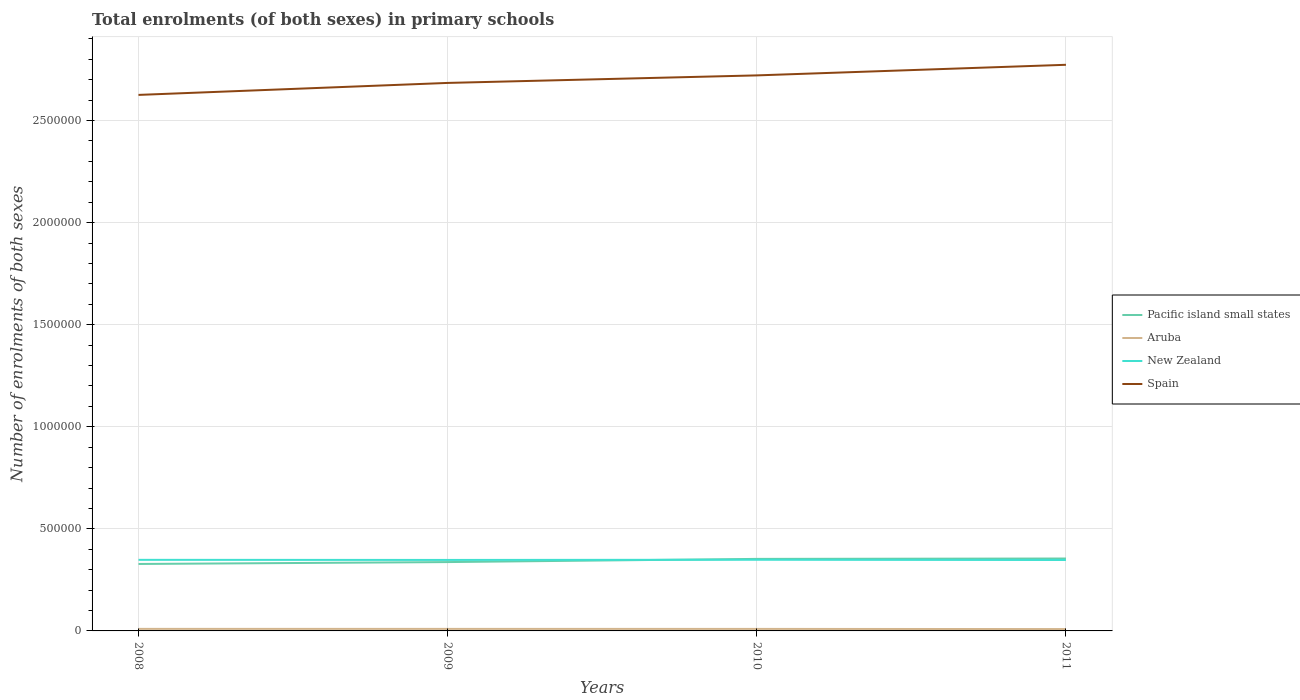How many different coloured lines are there?
Your answer should be very brief. 4. Does the line corresponding to New Zealand intersect with the line corresponding to Pacific island small states?
Your answer should be very brief. Yes. Across all years, what is the maximum number of enrolments in primary schools in New Zealand?
Ensure brevity in your answer.  3.47e+05. What is the total number of enrolments in primary schools in Aruba in the graph?
Your response must be concise. 86. What is the difference between the highest and the second highest number of enrolments in primary schools in Spain?
Keep it short and to the point. 1.47e+05. What is the difference between the highest and the lowest number of enrolments in primary schools in Spain?
Your response must be concise. 2. How many lines are there?
Offer a very short reply. 4. Where does the legend appear in the graph?
Your answer should be compact. Center right. How are the legend labels stacked?
Offer a terse response. Vertical. What is the title of the graph?
Provide a short and direct response. Total enrolments (of both sexes) in primary schools. Does "Dominican Republic" appear as one of the legend labels in the graph?
Make the answer very short. No. What is the label or title of the X-axis?
Keep it short and to the point. Years. What is the label or title of the Y-axis?
Offer a very short reply. Number of enrolments of both sexes. What is the Number of enrolments of both sexes of Pacific island small states in 2008?
Your answer should be compact. 3.28e+05. What is the Number of enrolments of both sexes in Aruba in 2008?
Ensure brevity in your answer.  1.00e+04. What is the Number of enrolments of both sexes in New Zealand in 2008?
Ensure brevity in your answer.  3.48e+05. What is the Number of enrolments of both sexes of Spain in 2008?
Give a very brief answer. 2.63e+06. What is the Number of enrolments of both sexes in Pacific island small states in 2009?
Keep it short and to the point. 3.37e+05. What is the Number of enrolments of both sexes in Aruba in 2009?
Keep it short and to the point. 9944. What is the Number of enrolments of both sexes of New Zealand in 2009?
Give a very brief answer. 3.48e+05. What is the Number of enrolments of both sexes of Spain in 2009?
Ensure brevity in your answer.  2.68e+06. What is the Number of enrolments of both sexes of Pacific island small states in 2010?
Keep it short and to the point. 3.53e+05. What is the Number of enrolments of both sexes in Aruba in 2010?
Give a very brief answer. 9858. What is the Number of enrolments of both sexes of New Zealand in 2010?
Offer a very short reply. 3.48e+05. What is the Number of enrolments of both sexes in Spain in 2010?
Make the answer very short. 2.72e+06. What is the Number of enrolments of both sexes of Pacific island small states in 2011?
Your response must be concise. 3.55e+05. What is the Number of enrolments of both sexes of Aruba in 2011?
Your answer should be very brief. 9112. What is the Number of enrolments of both sexes in New Zealand in 2011?
Offer a terse response. 3.47e+05. What is the Number of enrolments of both sexes of Spain in 2011?
Keep it short and to the point. 2.77e+06. Across all years, what is the maximum Number of enrolments of both sexes in Pacific island small states?
Give a very brief answer. 3.55e+05. Across all years, what is the maximum Number of enrolments of both sexes of Aruba?
Give a very brief answer. 1.00e+04. Across all years, what is the maximum Number of enrolments of both sexes in New Zealand?
Your answer should be very brief. 3.48e+05. Across all years, what is the maximum Number of enrolments of both sexes of Spain?
Your answer should be compact. 2.77e+06. Across all years, what is the minimum Number of enrolments of both sexes of Pacific island small states?
Your answer should be very brief. 3.28e+05. Across all years, what is the minimum Number of enrolments of both sexes of Aruba?
Your answer should be compact. 9112. Across all years, what is the minimum Number of enrolments of both sexes of New Zealand?
Offer a terse response. 3.47e+05. Across all years, what is the minimum Number of enrolments of both sexes of Spain?
Offer a very short reply. 2.63e+06. What is the total Number of enrolments of both sexes in Pacific island small states in the graph?
Keep it short and to the point. 1.37e+06. What is the total Number of enrolments of both sexes of Aruba in the graph?
Provide a short and direct response. 3.89e+04. What is the total Number of enrolments of both sexes of New Zealand in the graph?
Make the answer very short. 1.39e+06. What is the total Number of enrolments of both sexes in Spain in the graph?
Your response must be concise. 1.08e+07. What is the difference between the Number of enrolments of both sexes in Pacific island small states in 2008 and that in 2009?
Your answer should be compact. -9265.12. What is the difference between the Number of enrolments of both sexes of New Zealand in 2008 and that in 2009?
Your response must be concise. 486. What is the difference between the Number of enrolments of both sexes in Spain in 2008 and that in 2009?
Make the answer very short. -5.87e+04. What is the difference between the Number of enrolments of both sexes in Pacific island small states in 2008 and that in 2010?
Make the answer very short. -2.49e+04. What is the difference between the Number of enrolments of both sexes of Aruba in 2008 and that in 2010?
Give a very brief answer. 154. What is the difference between the Number of enrolments of both sexes in New Zealand in 2008 and that in 2010?
Give a very brief answer. -332. What is the difference between the Number of enrolments of both sexes of Spain in 2008 and that in 2010?
Provide a succinct answer. -9.56e+04. What is the difference between the Number of enrolments of both sexes in Pacific island small states in 2008 and that in 2011?
Offer a terse response. -2.67e+04. What is the difference between the Number of enrolments of both sexes of Aruba in 2008 and that in 2011?
Your answer should be compact. 900. What is the difference between the Number of enrolments of both sexes of New Zealand in 2008 and that in 2011?
Your answer should be very brief. 811. What is the difference between the Number of enrolments of both sexes of Spain in 2008 and that in 2011?
Offer a terse response. -1.47e+05. What is the difference between the Number of enrolments of both sexes of Pacific island small states in 2009 and that in 2010?
Keep it short and to the point. -1.56e+04. What is the difference between the Number of enrolments of both sexes of New Zealand in 2009 and that in 2010?
Offer a terse response. -818. What is the difference between the Number of enrolments of both sexes of Spain in 2009 and that in 2010?
Keep it short and to the point. -3.69e+04. What is the difference between the Number of enrolments of both sexes of Pacific island small states in 2009 and that in 2011?
Offer a terse response. -1.75e+04. What is the difference between the Number of enrolments of both sexes in Aruba in 2009 and that in 2011?
Provide a short and direct response. 832. What is the difference between the Number of enrolments of both sexes in New Zealand in 2009 and that in 2011?
Ensure brevity in your answer.  325. What is the difference between the Number of enrolments of both sexes in Spain in 2009 and that in 2011?
Provide a short and direct response. -8.88e+04. What is the difference between the Number of enrolments of both sexes in Pacific island small states in 2010 and that in 2011?
Provide a short and direct response. -1849.88. What is the difference between the Number of enrolments of both sexes in Aruba in 2010 and that in 2011?
Your answer should be very brief. 746. What is the difference between the Number of enrolments of both sexes of New Zealand in 2010 and that in 2011?
Your answer should be compact. 1143. What is the difference between the Number of enrolments of both sexes of Spain in 2010 and that in 2011?
Offer a very short reply. -5.19e+04. What is the difference between the Number of enrolments of both sexes in Pacific island small states in 2008 and the Number of enrolments of both sexes in Aruba in 2009?
Offer a very short reply. 3.18e+05. What is the difference between the Number of enrolments of both sexes in Pacific island small states in 2008 and the Number of enrolments of both sexes in New Zealand in 2009?
Your answer should be compact. -1.98e+04. What is the difference between the Number of enrolments of both sexes of Pacific island small states in 2008 and the Number of enrolments of both sexes of Spain in 2009?
Your answer should be very brief. -2.36e+06. What is the difference between the Number of enrolments of both sexes in Aruba in 2008 and the Number of enrolments of both sexes in New Zealand in 2009?
Offer a very short reply. -3.38e+05. What is the difference between the Number of enrolments of both sexes in Aruba in 2008 and the Number of enrolments of both sexes in Spain in 2009?
Keep it short and to the point. -2.67e+06. What is the difference between the Number of enrolments of both sexes in New Zealand in 2008 and the Number of enrolments of both sexes in Spain in 2009?
Provide a short and direct response. -2.34e+06. What is the difference between the Number of enrolments of both sexes in Pacific island small states in 2008 and the Number of enrolments of both sexes in Aruba in 2010?
Offer a terse response. 3.18e+05. What is the difference between the Number of enrolments of both sexes in Pacific island small states in 2008 and the Number of enrolments of both sexes in New Zealand in 2010?
Offer a very short reply. -2.06e+04. What is the difference between the Number of enrolments of both sexes in Pacific island small states in 2008 and the Number of enrolments of both sexes in Spain in 2010?
Provide a succinct answer. -2.39e+06. What is the difference between the Number of enrolments of both sexes in Aruba in 2008 and the Number of enrolments of both sexes in New Zealand in 2010?
Give a very brief answer. -3.38e+05. What is the difference between the Number of enrolments of both sexes in Aruba in 2008 and the Number of enrolments of both sexes in Spain in 2010?
Ensure brevity in your answer.  -2.71e+06. What is the difference between the Number of enrolments of both sexes of New Zealand in 2008 and the Number of enrolments of both sexes of Spain in 2010?
Provide a succinct answer. -2.37e+06. What is the difference between the Number of enrolments of both sexes in Pacific island small states in 2008 and the Number of enrolments of both sexes in Aruba in 2011?
Your answer should be very brief. 3.19e+05. What is the difference between the Number of enrolments of both sexes in Pacific island small states in 2008 and the Number of enrolments of both sexes in New Zealand in 2011?
Provide a short and direct response. -1.94e+04. What is the difference between the Number of enrolments of both sexes of Pacific island small states in 2008 and the Number of enrolments of both sexes of Spain in 2011?
Your answer should be very brief. -2.45e+06. What is the difference between the Number of enrolments of both sexes of Aruba in 2008 and the Number of enrolments of both sexes of New Zealand in 2011?
Offer a very short reply. -3.37e+05. What is the difference between the Number of enrolments of both sexes in Aruba in 2008 and the Number of enrolments of both sexes in Spain in 2011?
Offer a very short reply. -2.76e+06. What is the difference between the Number of enrolments of both sexes of New Zealand in 2008 and the Number of enrolments of both sexes of Spain in 2011?
Provide a short and direct response. -2.42e+06. What is the difference between the Number of enrolments of both sexes in Pacific island small states in 2009 and the Number of enrolments of both sexes in Aruba in 2010?
Your answer should be compact. 3.27e+05. What is the difference between the Number of enrolments of both sexes of Pacific island small states in 2009 and the Number of enrolments of both sexes of New Zealand in 2010?
Offer a very short reply. -1.13e+04. What is the difference between the Number of enrolments of both sexes in Pacific island small states in 2009 and the Number of enrolments of both sexes in Spain in 2010?
Give a very brief answer. -2.38e+06. What is the difference between the Number of enrolments of both sexes of Aruba in 2009 and the Number of enrolments of both sexes of New Zealand in 2010?
Provide a short and direct response. -3.39e+05. What is the difference between the Number of enrolments of both sexes in Aruba in 2009 and the Number of enrolments of both sexes in Spain in 2010?
Your answer should be compact. -2.71e+06. What is the difference between the Number of enrolments of both sexes in New Zealand in 2009 and the Number of enrolments of both sexes in Spain in 2010?
Offer a very short reply. -2.37e+06. What is the difference between the Number of enrolments of both sexes of Pacific island small states in 2009 and the Number of enrolments of both sexes of Aruba in 2011?
Your answer should be very brief. 3.28e+05. What is the difference between the Number of enrolments of both sexes in Pacific island small states in 2009 and the Number of enrolments of both sexes in New Zealand in 2011?
Keep it short and to the point. -1.02e+04. What is the difference between the Number of enrolments of both sexes in Pacific island small states in 2009 and the Number of enrolments of both sexes in Spain in 2011?
Ensure brevity in your answer.  -2.44e+06. What is the difference between the Number of enrolments of both sexes of Aruba in 2009 and the Number of enrolments of both sexes of New Zealand in 2011?
Your response must be concise. -3.37e+05. What is the difference between the Number of enrolments of both sexes in Aruba in 2009 and the Number of enrolments of both sexes in Spain in 2011?
Make the answer very short. -2.76e+06. What is the difference between the Number of enrolments of both sexes of New Zealand in 2009 and the Number of enrolments of both sexes of Spain in 2011?
Your answer should be very brief. -2.43e+06. What is the difference between the Number of enrolments of both sexes in Pacific island small states in 2010 and the Number of enrolments of both sexes in Aruba in 2011?
Offer a very short reply. 3.44e+05. What is the difference between the Number of enrolments of both sexes of Pacific island small states in 2010 and the Number of enrolments of both sexes of New Zealand in 2011?
Offer a terse response. 5432.78. What is the difference between the Number of enrolments of both sexes in Pacific island small states in 2010 and the Number of enrolments of both sexes in Spain in 2011?
Offer a very short reply. -2.42e+06. What is the difference between the Number of enrolments of both sexes of Aruba in 2010 and the Number of enrolments of both sexes of New Zealand in 2011?
Ensure brevity in your answer.  -3.37e+05. What is the difference between the Number of enrolments of both sexes in Aruba in 2010 and the Number of enrolments of both sexes in Spain in 2011?
Your answer should be compact. -2.76e+06. What is the difference between the Number of enrolments of both sexes in New Zealand in 2010 and the Number of enrolments of both sexes in Spain in 2011?
Ensure brevity in your answer.  -2.42e+06. What is the average Number of enrolments of both sexes of Pacific island small states per year?
Your answer should be compact. 3.43e+05. What is the average Number of enrolments of both sexes of Aruba per year?
Your answer should be very brief. 9731.5. What is the average Number of enrolments of both sexes in New Zealand per year?
Your answer should be very brief. 3.48e+05. What is the average Number of enrolments of both sexes in Spain per year?
Keep it short and to the point. 2.70e+06. In the year 2008, what is the difference between the Number of enrolments of both sexes of Pacific island small states and Number of enrolments of both sexes of Aruba?
Offer a very short reply. 3.18e+05. In the year 2008, what is the difference between the Number of enrolments of both sexes of Pacific island small states and Number of enrolments of both sexes of New Zealand?
Offer a very short reply. -2.03e+04. In the year 2008, what is the difference between the Number of enrolments of both sexes in Pacific island small states and Number of enrolments of both sexes in Spain?
Keep it short and to the point. -2.30e+06. In the year 2008, what is the difference between the Number of enrolments of both sexes in Aruba and Number of enrolments of both sexes in New Zealand?
Your answer should be very brief. -3.38e+05. In the year 2008, what is the difference between the Number of enrolments of both sexes of Aruba and Number of enrolments of both sexes of Spain?
Ensure brevity in your answer.  -2.62e+06. In the year 2008, what is the difference between the Number of enrolments of both sexes in New Zealand and Number of enrolments of both sexes in Spain?
Your response must be concise. -2.28e+06. In the year 2009, what is the difference between the Number of enrolments of both sexes of Pacific island small states and Number of enrolments of both sexes of Aruba?
Offer a very short reply. 3.27e+05. In the year 2009, what is the difference between the Number of enrolments of both sexes in Pacific island small states and Number of enrolments of both sexes in New Zealand?
Offer a terse response. -1.05e+04. In the year 2009, what is the difference between the Number of enrolments of both sexes in Pacific island small states and Number of enrolments of both sexes in Spain?
Your answer should be compact. -2.35e+06. In the year 2009, what is the difference between the Number of enrolments of both sexes of Aruba and Number of enrolments of both sexes of New Zealand?
Offer a terse response. -3.38e+05. In the year 2009, what is the difference between the Number of enrolments of both sexes in Aruba and Number of enrolments of both sexes in Spain?
Offer a terse response. -2.67e+06. In the year 2009, what is the difference between the Number of enrolments of both sexes of New Zealand and Number of enrolments of both sexes of Spain?
Keep it short and to the point. -2.34e+06. In the year 2010, what is the difference between the Number of enrolments of both sexes of Pacific island small states and Number of enrolments of both sexes of Aruba?
Make the answer very short. 3.43e+05. In the year 2010, what is the difference between the Number of enrolments of both sexes in Pacific island small states and Number of enrolments of both sexes in New Zealand?
Keep it short and to the point. 4289.78. In the year 2010, what is the difference between the Number of enrolments of both sexes in Pacific island small states and Number of enrolments of both sexes in Spain?
Your answer should be compact. -2.37e+06. In the year 2010, what is the difference between the Number of enrolments of both sexes in Aruba and Number of enrolments of both sexes in New Zealand?
Give a very brief answer. -3.39e+05. In the year 2010, what is the difference between the Number of enrolments of both sexes in Aruba and Number of enrolments of both sexes in Spain?
Offer a terse response. -2.71e+06. In the year 2010, what is the difference between the Number of enrolments of both sexes in New Zealand and Number of enrolments of both sexes in Spain?
Provide a short and direct response. -2.37e+06. In the year 2011, what is the difference between the Number of enrolments of both sexes in Pacific island small states and Number of enrolments of both sexes in Aruba?
Your answer should be compact. 3.46e+05. In the year 2011, what is the difference between the Number of enrolments of both sexes of Pacific island small states and Number of enrolments of both sexes of New Zealand?
Your answer should be compact. 7282.66. In the year 2011, what is the difference between the Number of enrolments of both sexes in Pacific island small states and Number of enrolments of both sexes in Spain?
Your answer should be very brief. -2.42e+06. In the year 2011, what is the difference between the Number of enrolments of both sexes in Aruba and Number of enrolments of both sexes in New Zealand?
Keep it short and to the point. -3.38e+05. In the year 2011, what is the difference between the Number of enrolments of both sexes in Aruba and Number of enrolments of both sexes in Spain?
Your response must be concise. -2.76e+06. In the year 2011, what is the difference between the Number of enrolments of both sexes in New Zealand and Number of enrolments of both sexes in Spain?
Offer a terse response. -2.43e+06. What is the ratio of the Number of enrolments of both sexes in Pacific island small states in 2008 to that in 2009?
Offer a very short reply. 0.97. What is the ratio of the Number of enrolments of both sexes of Aruba in 2008 to that in 2009?
Provide a short and direct response. 1.01. What is the ratio of the Number of enrolments of both sexes of New Zealand in 2008 to that in 2009?
Your answer should be very brief. 1. What is the ratio of the Number of enrolments of both sexes of Spain in 2008 to that in 2009?
Provide a short and direct response. 0.98. What is the ratio of the Number of enrolments of both sexes in Pacific island small states in 2008 to that in 2010?
Offer a terse response. 0.93. What is the ratio of the Number of enrolments of both sexes in Aruba in 2008 to that in 2010?
Your answer should be compact. 1.02. What is the ratio of the Number of enrolments of both sexes in Spain in 2008 to that in 2010?
Your answer should be compact. 0.96. What is the ratio of the Number of enrolments of both sexes of Pacific island small states in 2008 to that in 2011?
Make the answer very short. 0.92. What is the ratio of the Number of enrolments of both sexes in Aruba in 2008 to that in 2011?
Give a very brief answer. 1.1. What is the ratio of the Number of enrolments of both sexes in New Zealand in 2008 to that in 2011?
Provide a short and direct response. 1. What is the ratio of the Number of enrolments of both sexes in Spain in 2008 to that in 2011?
Give a very brief answer. 0.95. What is the ratio of the Number of enrolments of both sexes of Pacific island small states in 2009 to that in 2010?
Provide a short and direct response. 0.96. What is the ratio of the Number of enrolments of both sexes of Aruba in 2009 to that in 2010?
Keep it short and to the point. 1.01. What is the ratio of the Number of enrolments of both sexes in New Zealand in 2009 to that in 2010?
Ensure brevity in your answer.  1. What is the ratio of the Number of enrolments of both sexes of Spain in 2009 to that in 2010?
Your answer should be compact. 0.99. What is the ratio of the Number of enrolments of both sexes of Pacific island small states in 2009 to that in 2011?
Offer a very short reply. 0.95. What is the ratio of the Number of enrolments of both sexes of Aruba in 2009 to that in 2011?
Make the answer very short. 1.09. What is the ratio of the Number of enrolments of both sexes in Aruba in 2010 to that in 2011?
Keep it short and to the point. 1.08. What is the ratio of the Number of enrolments of both sexes in New Zealand in 2010 to that in 2011?
Ensure brevity in your answer.  1. What is the ratio of the Number of enrolments of both sexes of Spain in 2010 to that in 2011?
Your answer should be very brief. 0.98. What is the difference between the highest and the second highest Number of enrolments of both sexes in Pacific island small states?
Your answer should be compact. 1849.88. What is the difference between the highest and the second highest Number of enrolments of both sexes in Aruba?
Your answer should be very brief. 68. What is the difference between the highest and the second highest Number of enrolments of both sexes in New Zealand?
Your answer should be compact. 332. What is the difference between the highest and the second highest Number of enrolments of both sexes in Spain?
Your answer should be very brief. 5.19e+04. What is the difference between the highest and the lowest Number of enrolments of both sexes in Pacific island small states?
Offer a terse response. 2.67e+04. What is the difference between the highest and the lowest Number of enrolments of both sexes in Aruba?
Keep it short and to the point. 900. What is the difference between the highest and the lowest Number of enrolments of both sexes in New Zealand?
Ensure brevity in your answer.  1143. What is the difference between the highest and the lowest Number of enrolments of both sexes in Spain?
Ensure brevity in your answer.  1.47e+05. 